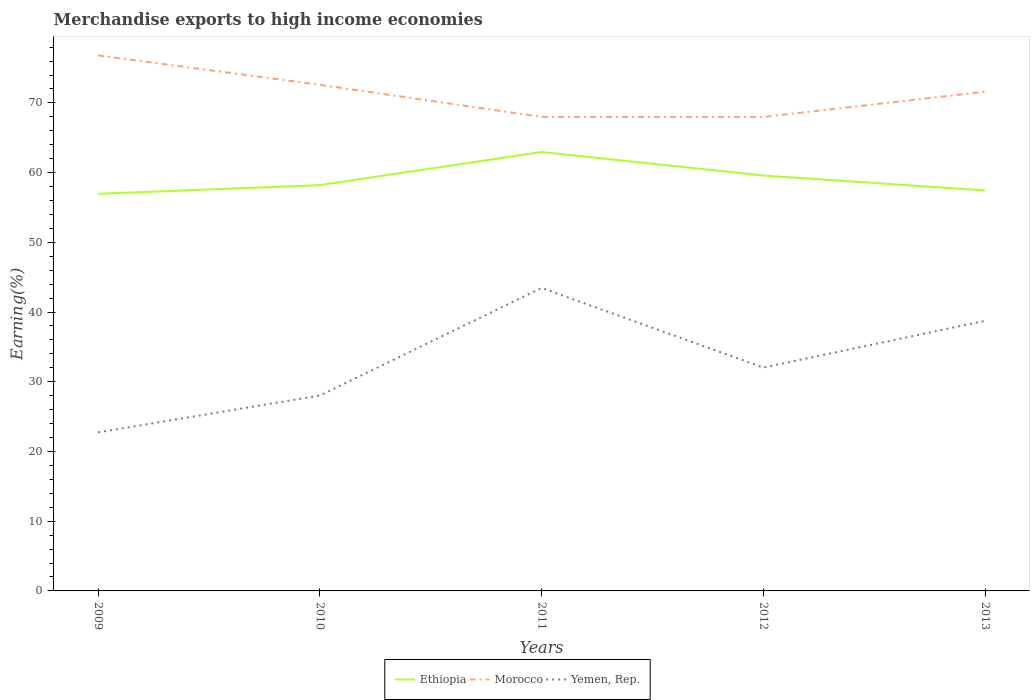Does the line corresponding to Ethiopia intersect with the line corresponding to Morocco?
Provide a short and direct response. No. Across all years, what is the maximum percentage of amount earned from merchandise exports in Ethiopia?
Provide a succinct answer. 56.96. In which year was the percentage of amount earned from merchandise exports in Yemen, Rep. maximum?
Give a very brief answer. 2009. What is the total percentage of amount earned from merchandise exports in Morocco in the graph?
Your response must be concise. 0.99. What is the difference between the highest and the second highest percentage of amount earned from merchandise exports in Yemen, Rep.?
Offer a very short reply. 20.72. What is the difference between the highest and the lowest percentage of amount earned from merchandise exports in Ethiopia?
Provide a short and direct response. 2. Is the percentage of amount earned from merchandise exports in Ethiopia strictly greater than the percentage of amount earned from merchandise exports in Morocco over the years?
Your answer should be very brief. Yes. How many lines are there?
Give a very brief answer. 3. How many years are there in the graph?
Your response must be concise. 5. What is the difference between two consecutive major ticks on the Y-axis?
Provide a short and direct response. 10. Are the values on the major ticks of Y-axis written in scientific E-notation?
Provide a succinct answer. No. Does the graph contain grids?
Offer a very short reply. No. How many legend labels are there?
Keep it short and to the point. 3. What is the title of the graph?
Provide a short and direct response. Merchandise exports to high income economies. Does "Upper middle income" appear as one of the legend labels in the graph?
Provide a succinct answer. No. What is the label or title of the X-axis?
Keep it short and to the point. Years. What is the label or title of the Y-axis?
Provide a succinct answer. Earning(%). What is the Earning(%) of Ethiopia in 2009?
Provide a short and direct response. 56.96. What is the Earning(%) of Morocco in 2009?
Offer a terse response. 76.81. What is the Earning(%) of Yemen, Rep. in 2009?
Ensure brevity in your answer.  22.74. What is the Earning(%) of Ethiopia in 2010?
Give a very brief answer. 58.21. What is the Earning(%) of Morocco in 2010?
Provide a succinct answer. 72.6. What is the Earning(%) in Yemen, Rep. in 2010?
Provide a short and direct response. 28.03. What is the Earning(%) in Ethiopia in 2011?
Give a very brief answer. 62.96. What is the Earning(%) of Morocco in 2011?
Make the answer very short. 68. What is the Earning(%) of Yemen, Rep. in 2011?
Offer a terse response. 43.46. What is the Earning(%) of Ethiopia in 2012?
Provide a succinct answer. 59.58. What is the Earning(%) of Morocco in 2012?
Provide a short and direct response. 67.98. What is the Earning(%) in Yemen, Rep. in 2012?
Your response must be concise. 32.04. What is the Earning(%) of Ethiopia in 2013?
Offer a very short reply. 57.44. What is the Earning(%) of Morocco in 2013?
Keep it short and to the point. 71.61. What is the Earning(%) in Yemen, Rep. in 2013?
Keep it short and to the point. 38.75. Across all years, what is the maximum Earning(%) in Ethiopia?
Offer a terse response. 62.96. Across all years, what is the maximum Earning(%) in Morocco?
Your response must be concise. 76.81. Across all years, what is the maximum Earning(%) of Yemen, Rep.?
Ensure brevity in your answer.  43.46. Across all years, what is the minimum Earning(%) in Ethiopia?
Your response must be concise. 56.96. Across all years, what is the minimum Earning(%) of Morocco?
Your response must be concise. 67.98. Across all years, what is the minimum Earning(%) of Yemen, Rep.?
Your answer should be compact. 22.74. What is the total Earning(%) of Ethiopia in the graph?
Offer a terse response. 295.16. What is the total Earning(%) in Morocco in the graph?
Make the answer very short. 357. What is the total Earning(%) of Yemen, Rep. in the graph?
Your answer should be very brief. 165.01. What is the difference between the Earning(%) of Ethiopia in 2009 and that in 2010?
Offer a terse response. -1.24. What is the difference between the Earning(%) of Morocco in 2009 and that in 2010?
Your response must be concise. 4.21. What is the difference between the Earning(%) of Yemen, Rep. in 2009 and that in 2010?
Offer a terse response. -5.28. What is the difference between the Earning(%) in Ethiopia in 2009 and that in 2011?
Provide a short and direct response. -6. What is the difference between the Earning(%) of Morocco in 2009 and that in 2011?
Make the answer very short. 8.82. What is the difference between the Earning(%) of Yemen, Rep. in 2009 and that in 2011?
Give a very brief answer. -20.72. What is the difference between the Earning(%) in Ethiopia in 2009 and that in 2012?
Keep it short and to the point. -2.62. What is the difference between the Earning(%) of Morocco in 2009 and that in 2012?
Ensure brevity in your answer.  8.83. What is the difference between the Earning(%) of Yemen, Rep. in 2009 and that in 2012?
Offer a terse response. -9.29. What is the difference between the Earning(%) of Ethiopia in 2009 and that in 2013?
Provide a succinct answer. -0.48. What is the difference between the Earning(%) of Morocco in 2009 and that in 2013?
Offer a terse response. 5.2. What is the difference between the Earning(%) in Yemen, Rep. in 2009 and that in 2013?
Your answer should be very brief. -16. What is the difference between the Earning(%) of Ethiopia in 2010 and that in 2011?
Your answer should be compact. -4.76. What is the difference between the Earning(%) in Morocco in 2010 and that in 2011?
Keep it short and to the point. 4.6. What is the difference between the Earning(%) of Yemen, Rep. in 2010 and that in 2011?
Make the answer very short. -15.43. What is the difference between the Earning(%) of Ethiopia in 2010 and that in 2012?
Your response must be concise. -1.38. What is the difference between the Earning(%) of Morocco in 2010 and that in 2012?
Keep it short and to the point. 4.62. What is the difference between the Earning(%) of Yemen, Rep. in 2010 and that in 2012?
Your answer should be very brief. -4.01. What is the difference between the Earning(%) of Ethiopia in 2010 and that in 2013?
Your answer should be very brief. 0.76. What is the difference between the Earning(%) of Morocco in 2010 and that in 2013?
Ensure brevity in your answer.  0.99. What is the difference between the Earning(%) of Yemen, Rep. in 2010 and that in 2013?
Offer a very short reply. -10.72. What is the difference between the Earning(%) of Ethiopia in 2011 and that in 2012?
Provide a succinct answer. 3.38. What is the difference between the Earning(%) of Morocco in 2011 and that in 2012?
Your response must be concise. 0.01. What is the difference between the Earning(%) in Yemen, Rep. in 2011 and that in 2012?
Give a very brief answer. 11.42. What is the difference between the Earning(%) in Ethiopia in 2011 and that in 2013?
Provide a short and direct response. 5.52. What is the difference between the Earning(%) of Morocco in 2011 and that in 2013?
Your answer should be compact. -3.61. What is the difference between the Earning(%) of Yemen, Rep. in 2011 and that in 2013?
Give a very brief answer. 4.71. What is the difference between the Earning(%) of Ethiopia in 2012 and that in 2013?
Offer a terse response. 2.14. What is the difference between the Earning(%) of Morocco in 2012 and that in 2013?
Make the answer very short. -3.63. What is the difference between the Earning(%) of Yemen, Rep. in 2012 and that in 2013?
Your response must be concise. -6.71. What is the difference between the Earning(%) of Ethiopia in 2009 and the Earning(%) of Morocco in 2010?
Make the answer very short. -15.63. What is the difference between the Earning(%) in Ethiopia in 2009 and the Earning(%) in Yemen, Rep. in 2010?
Your answer should be compact. 28.94. What is the difference between the Earning(%) of Morocco in 2009 and the Earning(%) of Yemen, Rep. in 2010?
Your answer should be compact. 48.79. What is the difference between the Earning(%) of Ethiopia in 2009 and the Earning(%) of Morocco in 2011?
Your answer should be compact. -11.03. What is the difference between the Earning(%) in Ethiopia in 2009 and the Earning(%) in Yemen, Rep. in 2011?
Your response must be concise. 13.5. What is the difference between the Earning(%) of Morocco in 2009 and the Earning(%) of Yemen, Rep. in 2011?
Offer a very short reply. 33.35. What is the difference between the Earning(%) in Ethiopia in 2009 and the Earning(%) in Morocco in 2012?
Give a very brief answer. -11.02. What is the difference between the Earning(%) in Ethiopia in 2009 and the Earning(%) in Yemen, Rep. in 2012?
Offer a very short reply. 24.93. What is the difference between the Earning(%) of Morocco in 2009 and the Earning(%) of Yemen, Rep. in 2012?
Your answer should be compact. 44.78. What is the difference between the Earning(%) in Ethiopia in 2009 and the Earning(%) in Morocco in 2013?
Your answer should be very brief. -14.64. What is the difference between the Earning(%) in Ethiopia in 2009 and the Earning(%) in Yemen, Rep. in 2013?
Provide a short and direct response. 18.22. What is the difference between the Earning(%) of Morocco in 2009 and the Earning(%) of Yemen, Rep. in 2013?
Offer a terse response. 38.07. What is the difference between the Earning(%) in Ethiopia in 2010 and the Earning(%) in Morocco in 2011?
Give a very brief answer. -9.79. What is the difference between the Earning(%) of Ethiopia in 2010 and the Earning(%) of Yemen, Rep. in 2011?
Offer a very short reply. 14.75. What is the difference between the Earning(%) in Morocco in 2010 and the Earning(%) in Yemen, Rep. in 2011?
Provide a succinct answer. 29.14. What is the difference between the Earning(%) of Ethiopia in 2010 and the Earning(%) of Morocco in 2012?
Offer a terse response. -9.77. What is the difference between the Earning(%) in Ethiopia in 2010 and the Earning(%) in Yemen, Rep. in 2012?
Your answer should be compact. 26.17. What is the difference between the Earning(%) in Morocco in 2010 and the Earning(%) in Yemen, Rep. in 2012?
Your response must be concise. 40.56. What is the difference between the Earning(%) of Ethiopia in 2010 and the Earning(%) of Morocco in 2013?
Ensure brevity in your answer.  -13.4. What is the difference between the Earning(%) in Ethiopia in 2010 and the Earning(%) in Yemen, Rep. in 2013?
Your answer should be compact. 19.46. What is the difference between the Earning(%) of Morocco in 2010 and the Earning(%) of Yemen, Rep. in 2013?
Offer a terse response. 33.85. What is the difference between the Earning(%) of Ethiopia in 2011 and the Earning(%) of Morocco in 2012?
Your answer should be very brief. -5.02. What is the difference between the Earning(%) of Ethiopia in 2011 and the Earning(%) of Yemen, Rep. in 2012?
Your response must be concise. 30.93. What is the difference between the Earning(%) of Morocco in 2011 and the Earning(%) of Yemen, Rep. in 2012?
Make the answer very short. 35.96. What is the difference between the Earning(%) of Ethiopia in 2011 and the Earning(%) of Morocco in 2013?
Your answer should be very brief. -8.64. What is the difference between the Earning(%) of Ethiopia in 2011 and the Earning(%) of Yemen, Rep. in 2013?
Your answer should be very brief. 24.22. What is the difference between the Earning(%) in Morocco in 2011 and the Earning(%) in Yemen, Rep. in 2013?
Provide a short and direct response. 29.25. What is the difference between the Earning(%) in Ethiopia in 2012 and the Earning(%) in Morocco in 2013?
Your answer should be very brief. -12.02. What is the difference between the Earning(%) in Ethiopia in 2012 and the Earning(%) in Yemen, Rep. in 2013?
Your answer should be compact. 20.84. What is the difference between the Earning(%) of Morocco in 2012 and the Earning(%) of Yemen, Rep. in 2013?
Your response must be concise. 29.24. What is the average Earning(%) of Ethiopia per year?
Offer a very short reply. 59.03. What is the average Earning(%) of Morocco per year?
Give a very brief answer. 71.4. What is the average Earning(%) of Yemen, Rep. per year?
Ensure brevity in your answer.  33. In the year 2009, what is the difference between the Earning(%) of Ethiopia and Earning(%) of Morocco?
Offer a terse response. -19.85. In the year 2009, what is the difference between the Earning(%) in Ethiopia and Earning(%) in Yemen, Rep.?
Ensure brevity in your answer.  34.22. In the year 2009, what is the difference between the Earning(%) in Morocco and Earning(%) in Yemen, Rep.?
Offer a terse response. 54.07. In the year 2010, what is the difference between the Earning(%) of Ethiopia and Earning(%) of Morocco?
Make the answer very short. -14.39. In the year 2010, what is the difference between the Earning(%) of Ethiopia and Earning(%) of Yemen, Rep.?
Make the answer very short. 30.18. In the year 2010, what is the difference between the Earning(%) of Morocco and Earning(%) of Yemen, Rep.?
Offer a very short reply. 44.57. In the year 2011, what is the difference between the Earning(%) in Ethiopia and Earning(%) in Morocco?
Your answer should be compact. -5.03. In the year 2011, what is the difference between the Earning(%) of Ethiopia and Earning(%) of Yemen, Rep.?
Provide a succinct answer. 19.5. In the year 2011, what is the difference between the Earning(%) of Morocco and Earning(%) of Yemen, Rep.?
Provide a succinct answer. 24.54. In the year 2012, what is the difference between the Earning(%) in Ethiopia and Earning(%) in Morocco?
Offer a very short reply. -8.4. In the year 2012, what is the difference between the Earning(%) in Ethiopia and Earning(%) in Yemen, Rep.?
Provide a short and direct response. 27.55. In the year 2012, what is the difference between the Earning(%) of Morocco and Earning(%) of Yemen, Rep.?
Give a very brief answer. 35.95. In the year 2013, what is the difference between the Earning(%) in Ethiopia and Earning(%) in Morocco?
Your answer should be very brief. -14.17. In the year 2013, what is the difference between the Earning(%) of Ethiopia and Earning(%) of Yemen, Rep.?
Keep it short and to the point. 18.7. In the year 2013, what is the difference between the Earning(%) in Morocco and Earning(%) in Yemen, Rep.?
Offer a very short reply. 32.86. What is the ratio of the Earning(%) of Ethiopia in 2009 to that in 2010?
Your answer should be compact. 0.98. What is the ratio of the Earning(%) in Morocco in 2009 to that in 2010?
Offer a very short reply. 1.06. What is the ratio of the Earning(%) in Yemen, Rep. in 2009 to that in 2010?
Keep it short and to the point. 0.81. What is the ratio of the Earning(%) of Ethiopia in 2009 to that in 2011?
Keep it short and to the point. 0.9. What is the ratio of the Earning(%) in Morocco in 2009 to that in 2011?
Ensure brevity in your answer.  1.13. What is the ratio of the Earning(%) of Yemen, Rep. in 2009 to that in 2011?
Offer a terse response. 0.52. What is the ratio of the Earning(%) in Ethiopia in 2009 to that in 2012?
Your answer should be very brief. 0.96. What is the ratio of the Earning(%) of Morocco in 2009 to that in 2012?
Provide a succinct answer. 1.13. What is the ratio of the Earning(%) in Yemen, Rep. in 2009 to that in 2012?
Offer a very short reply. 0.71. What is the ratio of the Earning(%) in Morocco in 2009 to that in 2013?
Give a very brief answer. 1.07. What is the ratio of the Earning(%) in Yemen, Rep. in 2009 to that in 2013?
Offer a terse response. 0.59. What is the ratio of the Earning(%) in Ethiopia in 2010 to that in 2011?
Offer a very short reply. 0.92. What is the ratio of the Earning(%) in Morocco in 2010 to that in 2011?
Provide a succinct answer. 1.07. What is the ratio of the Earning(%) in Yemen, Rep. in 2010 to that in 2011?
Make the answer very short. 0.64. What is the ratio of the Earning(%) in Ethiopia in 2010 to that in 2012?
Offer a terse response. 0.98. What is the ratio of the Earning(%) in Morocco in 2010 to that in 2012?
Give a very brief answer. 1.07. What is the ratio of the Earning(%) in Yemen, Rep. in 2010 to that in 2012?
Make the answer very short. 0.87. What is the ratio of the Earning(%) of Ethiopia in 2010 to that in 2013?
Make the answer very short. 1.01. What is the ratio of the Earning(%) of Morocco in 2010 to that in 2013?
Offer a very short reply. 1.01. What is the ratio of the Earning(%) in Yemen, Rep. in 2010 to that in 2013?
Your response must be concise. 0.72. What is the ratio of the Earning(%) in Ethiopia in 2011 to that in 2012?
Provide a succinct answer. 1.06. What is the ratio of the Earning(%) in Yemen, Rep. in 2011 to that in 2012?
Provide a short and direct response. 1.36. What is the ratio of the Earning(%) in Ethiopia in 2011 to that in 2013?
Your answer should be very brief. 1.1. What is the ratio of the Earning(%) in Morocco in 2011 to that in 2013?
Keep it short and to the point. 0.95. What is the ratio of the Earning(%) of Yemen, Rep. in 2011 to that in 2013?
Keep it short and to the point. 1.12. What is the ratio of the Earning(%) of Ethiopia in 2012 to that in 2013?
Provide a short and direct response. 1.04. What is the ratio of the Earning(%) in Morocco in 2012 to that in 2013?
Your response must be concise. 0.95. What is the ratio of the Earning(%) of Yemen, Rep. in 2012 to that in 2013?
Your answer should be compact. 0.83. What is the difference between the highest and the second highest Earning(%) of Ethiopia?
Your answer should be very brief. 3.38. What is the difference between the highest and the second highest Earning(%) in Morocco?
Keep it short and to the point. 4.21. What is the difference between the highest and the second highest Earning(%) of Yemen, Rep.?
Provide a succinct answer. 4.71. What is the difference between the highest and the lowest Earning(%) of Ethiopia?
Your answer should be compact. 6. What is the difference between the highest and the lowest Earning(%) in Morocco?
Keep it short and to the point. 8.83. What is the difference between the highest and the lowest Earning(%) of Yemen, Rep.?
Make the answer very short. 20.72. 